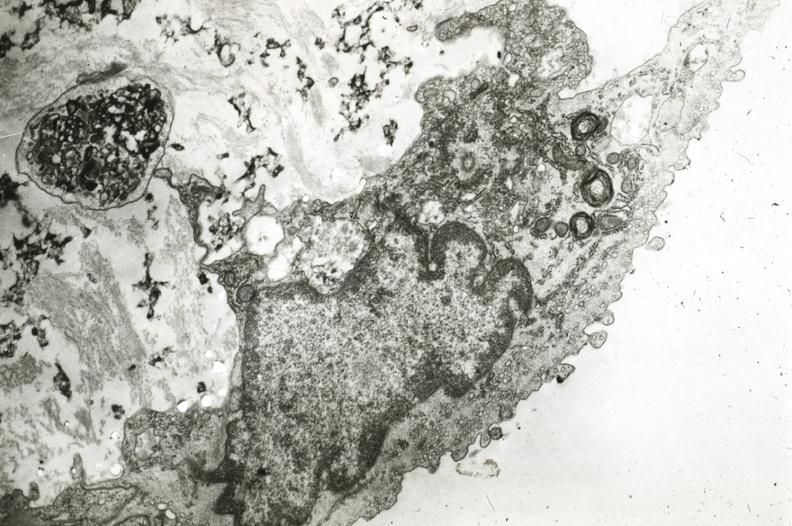what is present?
Answer the question using a single word or phrase. Cardiovascular 